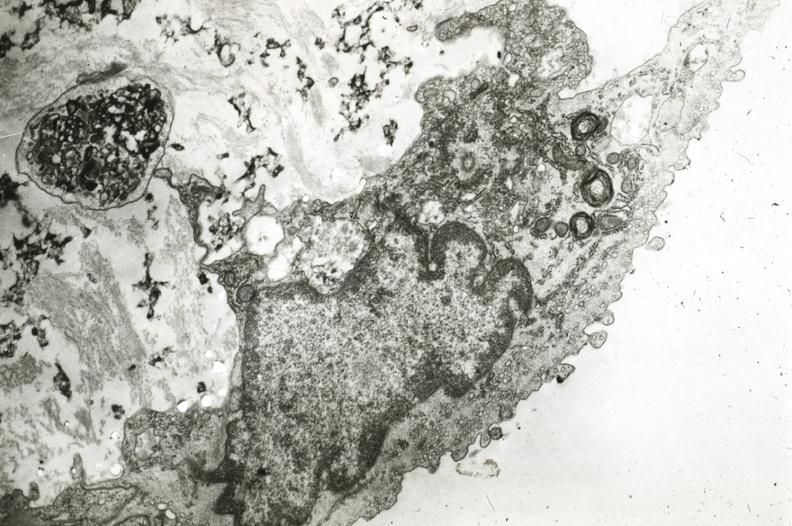what is present?
Answer the question using a single word or phrase. Cardiovascular 